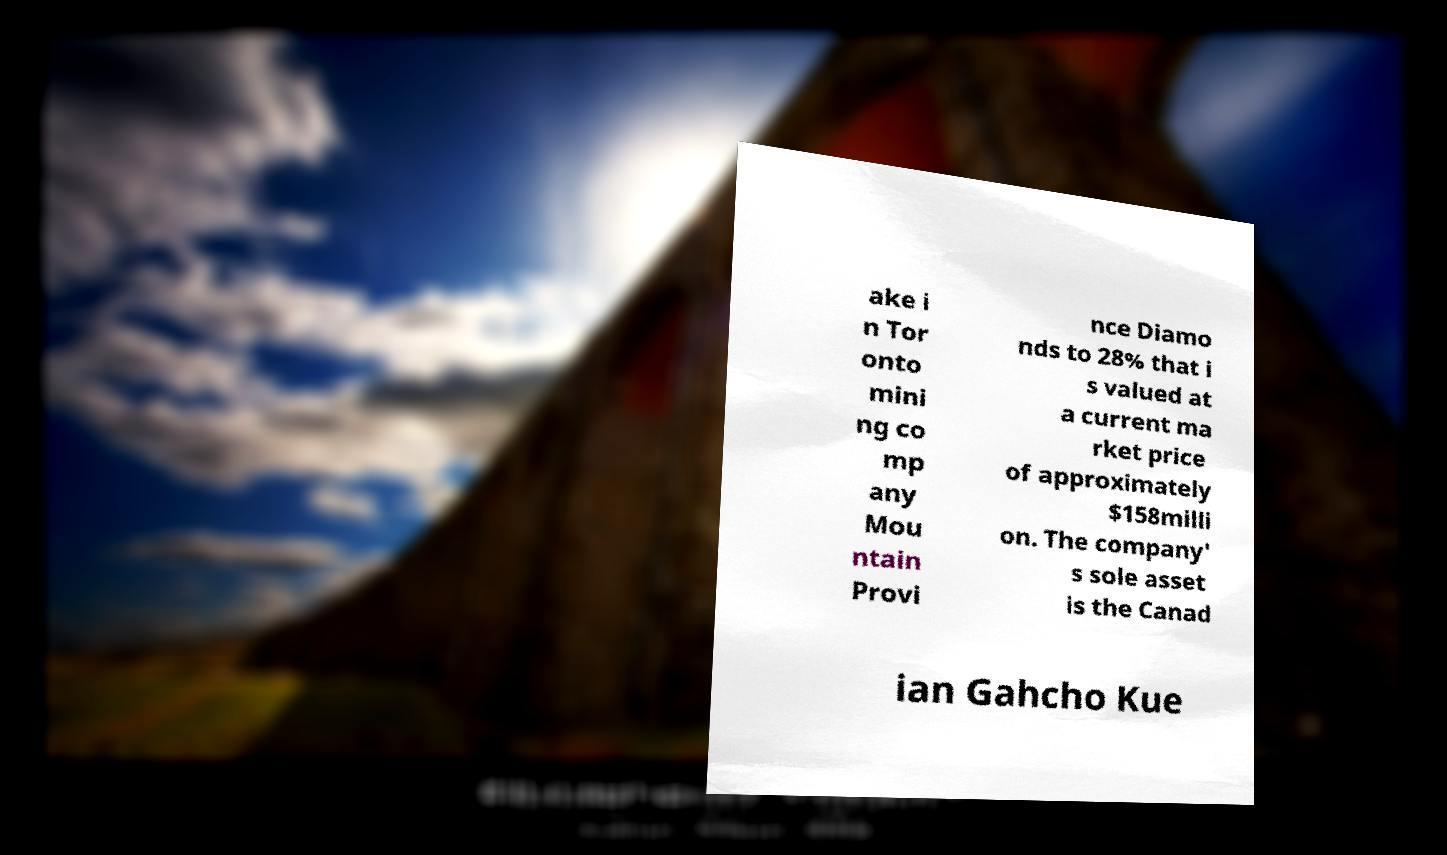Could you extract and type out the text from this image? ake i n Tor onto mini ng co mp any Mou ntain Provi nce Diamo nds to 28% that i s valued at a current ma rket price of approximately $158milli on. The company' s sole asset is the Canad ian Gahcho Kue 